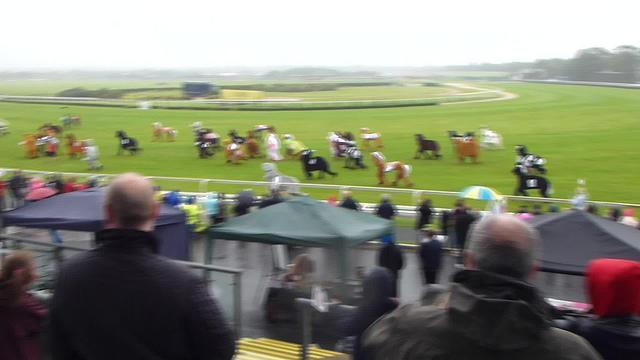How many tents are in the image?
Give a very brief answer. 3. How many umbrellas are visible?
Give a very brief answer. 2. How many people can be seen?
Give a very brief answer. 5. 